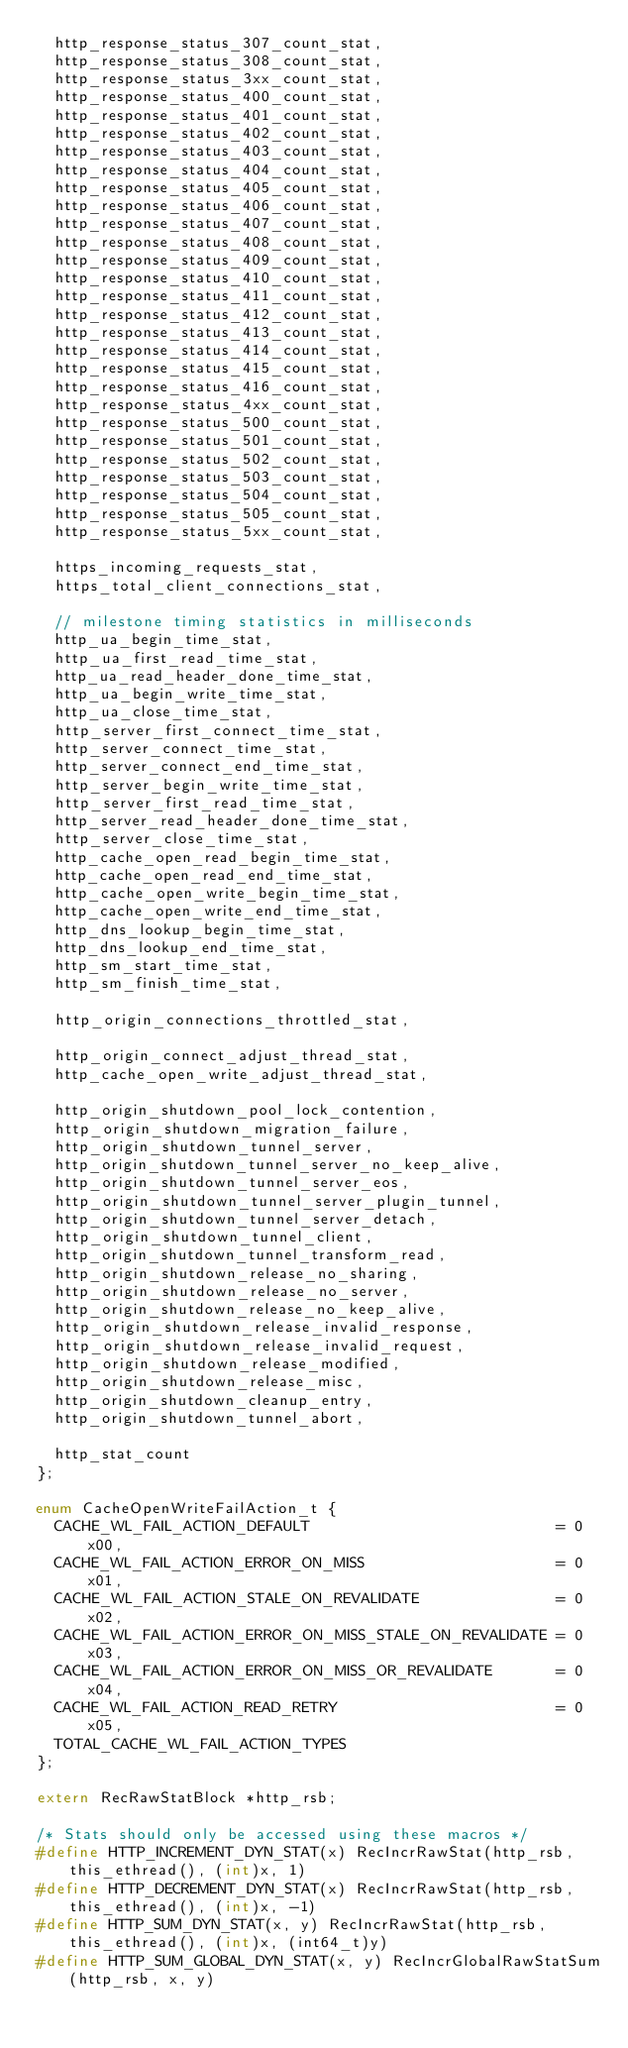Convert code to text. <code><loc_0><loc_0><loc_500><loc_500><_C_>  http_response_status_307_count_stat,
  http_response_status_308_count_stat,
  http_response_status_3xx_count_stat,
  http_response_status_400_count_stat,
  http_response_status_401_count_stat,
  http_response_status_402_count_stat,
  http_response_status_403_count_stat,
  http_response_status_404_count_stat,
  http_response_status_405_count_stat,
  http_response_status_406_count_stat,
  http_response_status_407_count_stat,
  http_response_status_408_count_stat,
  http_response_status_409_count_stat,
  http_response_status_410_count_stat,
  http_response_status_411_count_stat,
  http_response_status_412_count_stat,
  http_response_status_413_count_stat,
  http_response_status_414_count_stat,
  http_response_status_415_count_stat,
  http_response_status_416_count_stat,
  http_response_status_4xx_count_stat,
  http_response_status_500_count_stat,
  http_response_status_501_count_stat,
  http_response_status_502_count_stat,
  http_response_status_503_count_stat,
  http_response_status_504_count_stat,
  http_response_status_505_count_stat,
  http_response_status_5xx_count_stat,

  https_incoming_requests_stat,
  https_total_client_connections_stat,

  // milestone timing statistics in milliseconds
  http_ua_begin_time_stat,
  http_ua_first_read_time_stat,
  http_ua_read_header_done_time_stat,
  http_ua_begin_write_time_stat,
  http_ua_close_time_stat,
  http_server_first_connect_time_stat,
  http_server_connect_time_stat,
  http_server_connect_end_time_stat,
  http_server_begin_write_time_stat,
  http_server_first_read_time_stat,
  http_server_read_header_done_time_stat,
  http_server_close_time_stat,
  http_cache_open_read_begin_time_stat,
  http_cache_open_read_end_time_stat,
  http_cache_open_write_begin_time_stat,
  http_cache_open_write_end_time_stat,
  http_dns_lookup_begin_time_stat,
  http_dns_lookup_end_time_stat,
  http_sm_start_time_stat,
  http_sm_finish_time_stat,

  http_origin_connections_throttled_stat,

  http_origin_connect_adjust_thread_stat,
  http_cache_open_write_adjust_thread_stat,

  http_origin_shutdown_pool_lock_contention,
  http_origin_shutdown_migration_failure,
  http_origin_shutdown_tunnel_server,
  http_origin_shutdown_tunnel_server_no_keep_alive,
  http_origin_shutdown_tunnel_server_eos,
  http_origin_shutdown_tunnel_server_plugin_tunnel,
  http_origin_shutdown_tunnel_server_detach,
  http_origin_shutdown_tunnel_client,
  http_origin_shutdown_tunnel_transform_read,
  http_origin_shutdown_release_no_sharing,
  http_origin_shutdown_release_no_server,
  http_origin_shutdown_release_no_keep_alive,
  http_origin_shutdown_release_invalid_response,
  http_origin_shutdown_release_invalid_request,
  http_origin_shutdown_release_modified,
  http_origin_shutdown_release_misc,
  http_origin_shutdown_cleanup_entry,
  http_origin_shutdown_tunnel_abort,

  http_stat_count
};

enum CacheOpenWriteFailAction_t {
  CACHE_WL_FAIL_ACTION_DEFAULT                           = 0x00,
  CACHE_WL_FAIL_ACTION_ERROR_ON_MISS                     = 0x01,
  CACHE_WL_FAIL_ACTION_STALE_ON_REVALIDATE               = 0x02,
  CACHE_WL_FAIL_ACTION_ERROR_ON_MISS_STALE_ON_REVALIDATE = 0x03,
  CACHE_WL_FAIL_ACTION_ERROR_ON_MISS_OR_REVALIDATE       = 0x04,
  CACHE_WL_FAIL_ACTION_READ_RETRY                        = 0x05,
  TOTAL_CACHE_WL_FAIL_ACTION_TYPES
};

extern RecRawStatBlock *http_rsb;

/* Stats should only be accessed using these macros */
#define HTTP_INCREMENT_DYN_STAT(x) RecIncrRawStat(http_rsb, this_ethread(), (int)x, 1)
#define HTTP_DECREMENT_DYN_STAT(x) RecIncrRawStat(http_rsb, this_ethread(), (int)x, -1)
#define HTTP_SUM_DYN_STAT(x, y) RecIncrRawStat(http_rsb, this_ethread(), (int)x, (int64_t)y)
#define HTTP_SUM_GLOBAL_DYN_STAT(x, y) RecIncrGlobalRawStatSum(http_rsb, x, y)
</code> 